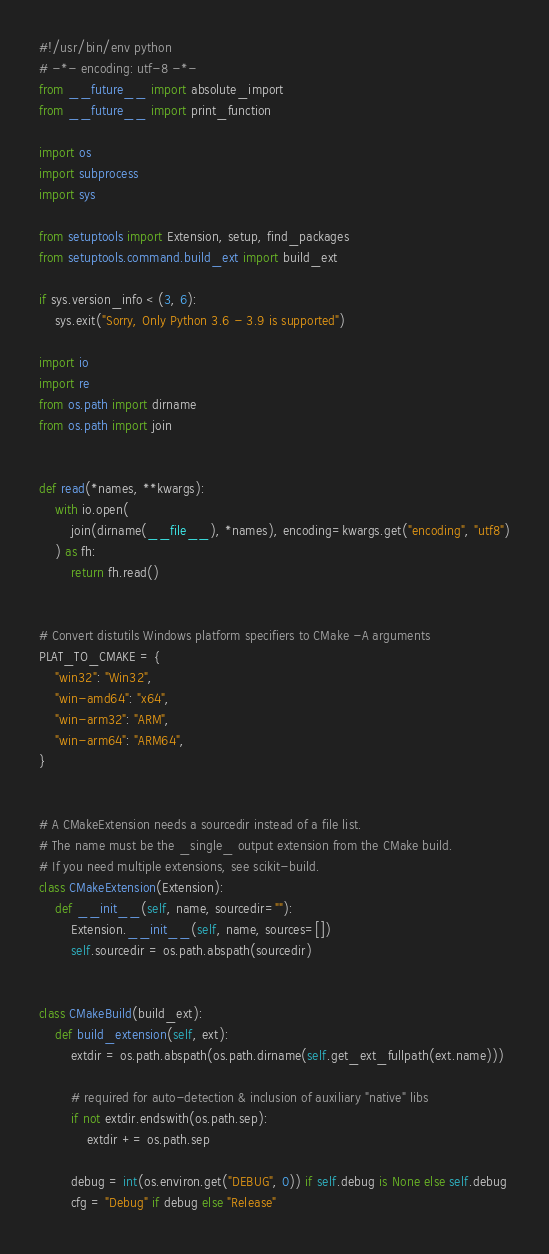<code> <loc_0><loc_0><loc_500><loc_500><_Python_>#!/usr/bin/env python
# -*- encoding: utf-8 -*-
from __future__ import absolute_import
from __future__ import print_function

import os
import subprocess
import sys

from setuptools import Extension, setup, find_packages
from setuptools.command.build_ext import build_ext

if sys.version_info < (3, 6):
    sys.exit("Sorry, Only Python 3.6 - 3.9 is supported")

import io
import re
from os.path import dirname
from os.path import join


def read(*names, **kwargs):
    with io.open(
        join(dirname(__file__), *names), encoding=kwargs.get("encoding", "utf8")
    ) as fh:
        return fh.read()


# Convert distutils Windows platform specifiers to CMake -A arguments
PLAT_TO_CMAKE = {
    "win32": "Win32",
    "win-amd64": "x64",
    "win-arm32": "ARM",
    "win-arm64": "ARM64",
}


# A CMakeExtension needs a sourcedir instead of a file list.
# The name must be the _single_ output extension from the CMake build.
# If you need multiple extensions, see scikit-build.
class CMakeExtension(Extension):
    def __init__(self, name, sourcedir=""):
        Extension.__init__(self, name, sources=[])
        self.sourcedir = os.path.abspath(sourcedir)


class CMakeBuild(build_ext):
    def build_extension(self, ext):
        extdir = os.path.abspath(os.path.dirname(self.get_ext_fullpath(ext.name)))

        # required for auto-detection & inclusion of auxiliary "native" libs
        if not extdir.endswith(os.path.sep):
            extdir += os.path.sep

        debug = int(os.environ.get("DEBUG", 0)) if self.debug is None else self.debug
        cfg = "Debug" if debug else "Release"
</code> 